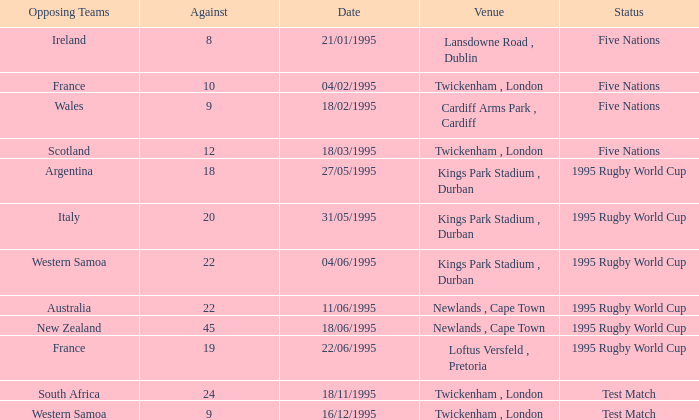What's the status on 16/12/1995? Test Match. 